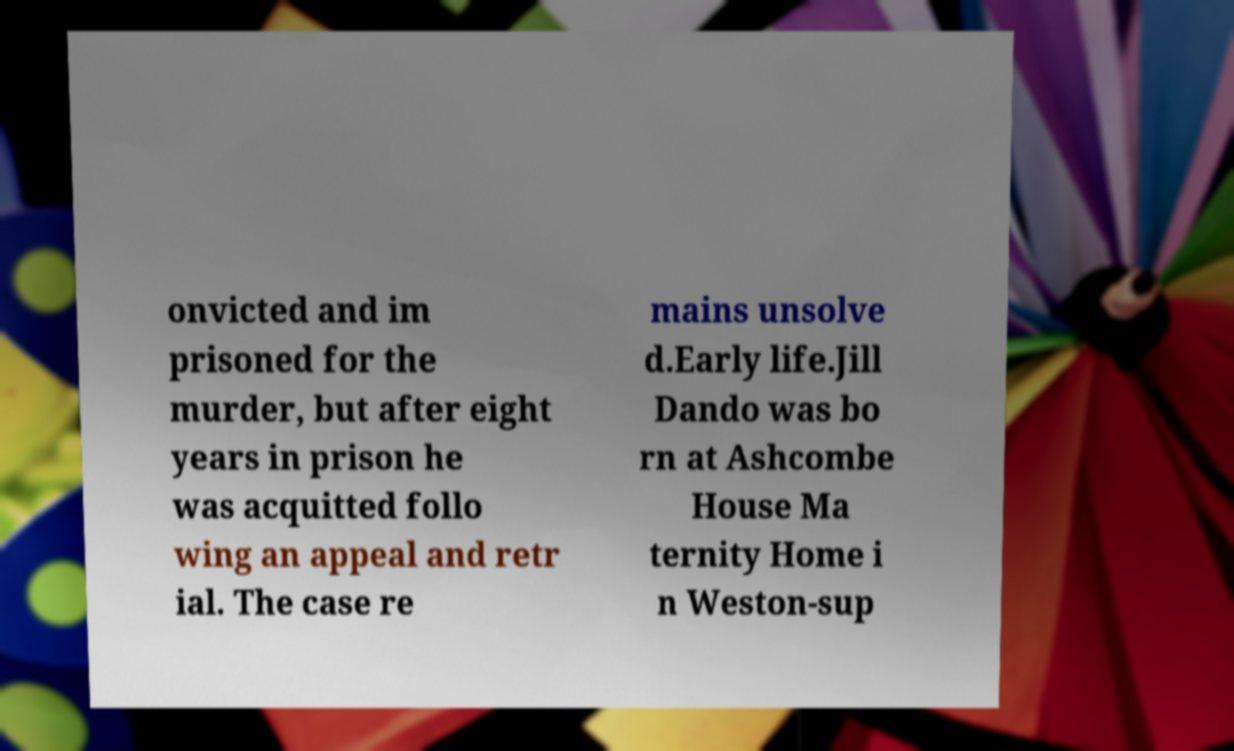Can you accurately transcribe the text from the provided image for me? onvicted and im prisoned for the murder, but after eight years in prison he was acquitted follo wing an appeal and retr ial. The case re mains unsolve d.Early life.Jill Dando was bo rn at Ashcombe House Ma ternity Home i n Weston-sup 